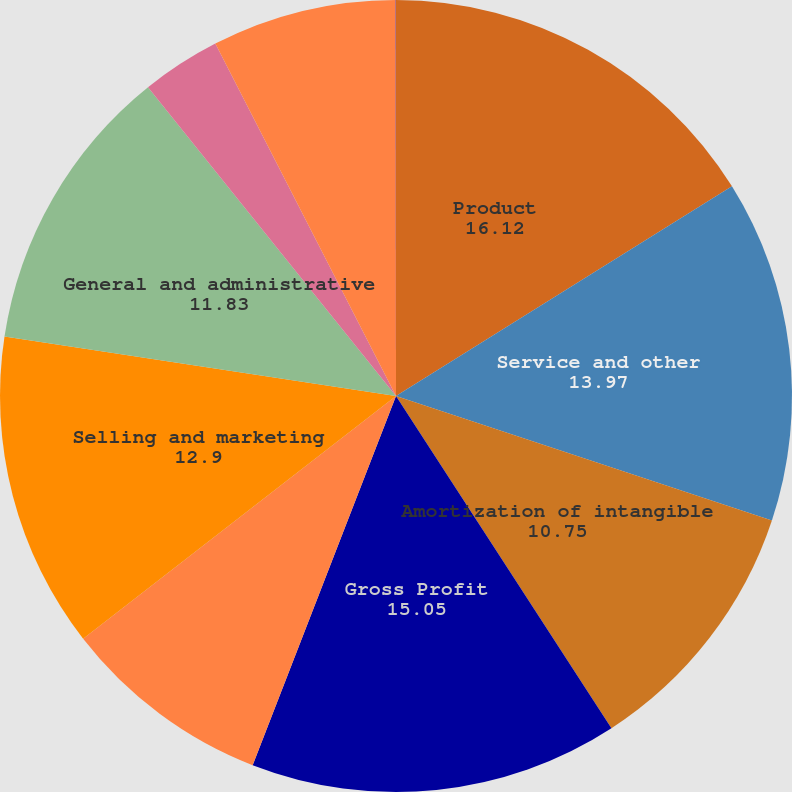Convert chart. <chart><loc_0><loc_0><loc_500><loc_500><pie_chart><fcel>Product<fcel>Service and other<fcel>Amortization of intangible<fcel>Gross Profit<fcel>Research and development<fcel>Selling and marketing<fcel>General and administrative<fcel>Restructuring and divestiture<fcel>Income (loss) from operations<fcel>Interest income<nl><fcel>16.12%<fcel>13.97%<fcel>10.75%<fcel>15.05%<fcel>8.6%<fcel>12.9%<fcel>11.83%<fcel>3.23%<fcel>7.53%<fcel>0.01%<nl></chart> 